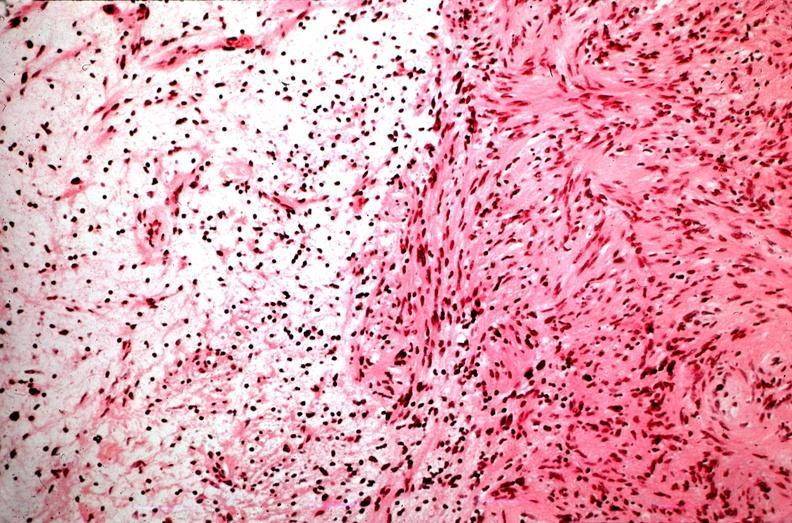does opened muscle show schwannoma, antoni a and antoni b patterns?
Answer the question using a single word or phrase. No 